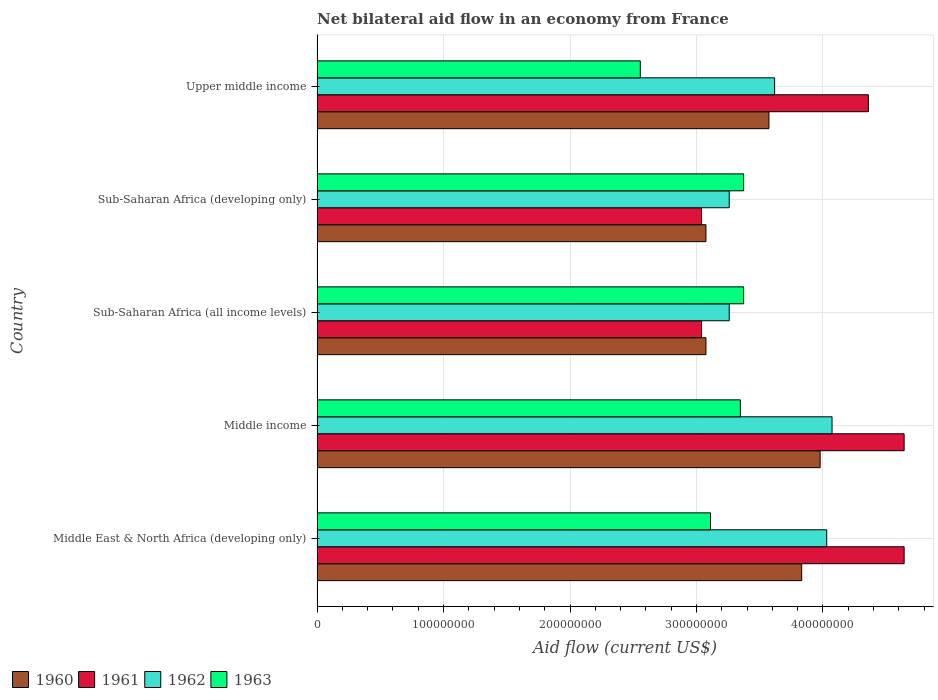Are the number of bars per tick equal to the number of legend labels?
Your answer should be very brief. Yes. In how many cases, is the number of bars for a given country not equal to the number of legend labels?
Your response must be concise. 0. What is the net bilateral aid flow in 1963 in Sub-Saharan Africa (developing only)?
Make the answer very short. 3.37e+08. Across all countries, what is the maximum net bilateral aid flow in 1963?
Ensure brevity in your answer.  3.37e+08. Across all countries, what is the minimum net bilateral aid flow in 1960?
Give a very brief answer. 3.08e+08. In which country was the net bilateral aid flow in 1961 maximum?
Ensure brevity in your answer.  Middle East & North Africa (developing only). In which country was the net bilateral aid flow in 1960 minimum?
Offer a terse response. Sub-Saharan Africa (all income levels). What is the total net bilateral aid flow in 1963 in the graph?
Provide a short and direct response. 1.58e+09. What is the difference between the net bilateral aid flow in 1963 in Sub-Saharan Africa (all income levels) and the net bilateral aid flow in 1962 in Middle income?
Give a very brief answer. -6.99e+07. What is the average net bilateral aid flow in 1960 per country?
Your answer should be compact. 3.51e+08. What is the difference between the net bilateral aid flow in 1963 and net bilateral aid flow in 1962 in Middle East & North Africa (developing only)?
Ensure brevity in your answer.  -9.19e+07. What is the ratio of the net bilateral aid flow in 1961 in Middle income to that in Sub-Saharan Africa (all income levels)?
Your response must be concise. 1.53. Is the net bilateral aid flow in 1960 in Sub-Saharan Africa (all income levels) less than that in Upper middle income?
Give a very brief answer. Yes. Is the difference between the net bilateral aid flow in 1963 in Sub-Saharan Africa (all income levels) and Upper middle income greater than the difference between the net bilateral aid flow in 1962 in Sub-Saharan Africa (all income levels) and Upper middle income?
Your answer should be very brief. Yes. What is the difference between the highest and the second highest net bilateral aid flow in 1960?
Offer a very short reply. 1.46e+07. What is the difference between the highest and the lowest net bilateral aid flow in 1962?
Offer a very short reply. 8.13e+07. Is it the case that in every country, the sum of the net bilateral aid flow in 1962 and net bilateral aid flow in 1963 is greater than the sum of net bilateral aid flow in 1961 and net bilateral aid flow in 1960?
Provide a succinct answer. No. How many bars are there?
Give a very brief answer. 20. How many countries are there in the graph?
Your answer should be very brief. 5. What is the difference between two consecutive major ticks on the X-axis?
Provide a short and direct response. 1.00e+08. Are the values on the major ticks of X-axis written in scientific E-notation?
Offer a very short reply. No. Does the graph contain any zero values?
Provide a succinct answer. No. Does the graph contain grids?
Make the answer very short. Yes. Where does the legend appear in the graph?
Provide a succinct answer. Bottom left. What is the title of the graph?
Make the answer very short. Net bilateral aid flow in an economy from France. What is the label or title of the X-axis?
Give a very brief answer. Aid flow (current US$). What is the Aid flow (current US$) in 1960 in Middle East & North Africa (developing only)?
Offer a very short reply. 3.83e+08. What is the Aid flow (current US$) of 1961 in Middle East & North Africa (developing only)?
Offer a very short reply. 4.64e+08. What is the Aid flow (current US$) in 1962 in Middle East & North Africa (developing only)?
Give a very brief answer. 4.03e+08. What is the Aid flow (current US$) in 1963 in Middle East & North Africa (developing only)?
Keep it short and to the point. 3.11e+08. What is the Aid flow (current US$) in 1960 in Middle income?
Provide a short and direct response. 3.98e+08. What is the Aid flow (current US$) of 1961 in Middle income?
Offer a terse response. 4.64e+08. What is the Aid flow (current US$) of 1962 in Middle income?
Give a very brief answer. 4.07e+08. What is the Aid flow (current US$) of 1963 in Middle income?
Provide a succinct answer. 3.35e+08. What is the Aid flow (current US$) of 1960 in Sub-Saharan Africa (all income levels)?
Provide a succinct answer. 3.08e+08. What is the Aid flow (current US$) in 1961 in Sub-Saharan Africa (all income levels)?
Give a very brief answer. 3.04e+08. What is the Aid flow (current US$) in 1962 in Sub-Saharan Africa (all income levels)?
Provide a succinct answer. 3.26e+08. What is the Aid flow (current US$) in 1963 in Sub-Saharan Africa (all income levels)?
Offer a very short reply. 3.37e+08. What is the Aid flow (current US$) in 1960 in Sub-Saharan Africa (developing only)?
Provide a succinct answer. 3.08e+08. What is the Aid flow (current US$) of 1961 in Sub-Saharan Africa (developing only)?
Give a very brief answer. 3.04e+08. What is the Aid flow (current US$) in 1962 in Sub-Saharan Africa (developing only)?
Offer a very short reply. 3.26e+08. What is the Aid flow (current US$) of 1963 in Sub-Saharan Africa (developing only)?
Keep it short and to the point. 3.37e+08. What is the Aid flow (current US$) of 1960 in Upper middle income?
Provide a short and direct response. 3.57e+08. What is the Aid flow (current US$) in 1961 in Upper middle income?
Ensure brevity in your answer.  4.36e+08. What is the Aid flow (current US$) of 1962 in Upper middle income?
Make the answer very short. 3.62e+08. What is the Aid flow (current US$) in 1963 in Upper middle income?
Your response must be concise. 2.56e+08. Across all countries, what is the maximum Aid flow (current US$) in 1960?
Provide a short and direct response. 3.98e+08. Across all countries, what is the maximum Aid flow (current US$) of 1961?
Provide a succinct answer. 4.64e+08. Across all countries, what is the maximum Aid flow (current US$) in 1962?
Ensure brevity in your answer.  4.07e+08. Across all countries, what is the maximum Aid flow (current US$) in 1963?
Keep it short and to the point. 3.37e+08. Across all countries, what is the minimum Aid flow (current US$) in 1960?
Your answer should be very brief. 3.08e+08. Across all countries, what is the minimum Aid flow (current US$) of 1961?
Make the answer very short. 3.04e+08. Across all countries, what is the minimum Aid flow (current US$) of 1962?
Your response must be concise. 3.26e+08. Across all countries, what is the minimum Aid flow (current US$) of 1963?
Ensure brevity in your answer.  2.56e+08. What is the total Aid flow (current US$) in 1960 in the graph?
Ensure brevity in your answer.  1.75e+09. What is the total Aid flow (current US$) of 1961 in the graph?
Give a very brief answer. 1.97e+09. What is the total Aid flow (current US$) of 1962 in the graph?
Ensure brevity in your answer.  1.82e+09. What is the total Aid flow (current US$) in 1963 in the graph?
Give a very brief answer. 1.58e+09. What is the difference between the Aid flow (current US$) in 1960 in Middle East & North Africa (developing only) and that in Middle income?
Offer a terse response. -1.46e+07. What is the difference between the Aid flow (current US$) of 1961 in Middle East & North Africa (developing only) and that in Middle income?
Offer a very short reply. 0. What is the difference between the Aid flow (current US$) of 1962 in Middle East & North Africa (developing only) and that in Middle income?
Your response must be concise. -4.20e+06. What is the difference between the Aid flow (current US$) of 1963 in Middle East & North Africa (developing only) and that in Middle income?
Make the answer very short. -2.36e+07. What is the difference between the Aid flow (current US$) of 1960 in Middle East & North Africa (developing only) and that in Sub-Saharan Africa (all income levels)?
Provide a short and direct response. 7.57e+07. What is the difference between the Aid flow (current US$) in 1961 in Middle East & North Africa (developing only) and that in Sub-Saharan Africa (all income levels)?
Your response must be concise. 1.60e+08. What is the difference between the Aid flow (current US$) in 1962 in Middle East & North Africa (developing only) and that in Sub-Saharan Africa (all income levels)?
Give a very brief answer. 7.71e+07. What is the difference between the Aid flow (current US$) in 1963 in Middle East & North Africa (developing only) and that in Sub-Saharan Africa (all income levels)?
Provide a succinct answer. -2.62e+07. What is the difference between the Aid flow (current US$) of 1960 in Middle East & North Africa (developing only) and that in Sub-Saharan Africa (developing only)?
Make the answer very short. 7.57e+07. What is the difference between the Aid flow (current US$) of 1961 in Middle East & North Africa (developing only) and that in Sub-Saharan Africa (developing only)?
Offer a very short reply. 1.60e+08. What is the difference between the Aid flow (current US$) of 1962 in Middle East & North Africa (developing only) and that in Sub-Saharan Africa (developing only)?
Provide a short and direct response. 7.71e+07. What is the difference between the Aid flow (current US$) in 1963 in Middle East & North Africa (developing only) and that in Sub-Saharan Africa (developing only)?
Offer a very short reply. -2.62e+07. What is the difference between the Aid flow (current US$) of 1960 in Middle East & North Africa (developing only) and that in Upper middle income?
Your answer should be very brief. 2.59e+07. What is the difference between the Aid flow (current US$) in 1961 in Middle East & North Africa (developing only) and that in Upper middle income?
Offer a terse response. 2.83e+07. What is the difference between the Aid flow (current US$) in 1962 in Middle East & North Africa (developing only) and that in Upper middle income?
Offer a very short reply. 4.12e+07. What is the difference between the Aid flow (current US$) of 1963 in Middle East & North Africa (developing only) and that in Upper middle income?
Ensure brevity in your answer.  5.55e+07. What is the difference between the Aid flow (current US$) in 1960 in Middle income and that in Sub-Saharan Africa (all income levels)?
Provide a short and direct response. 9.03e+07. What is the difference between the Aid flow (current US$) in 1961 in Middle income and that in Sub-Saharan Africa (all income levels)?
Give a very brief answer. 1.60e+08. What is the difference between the Aid flow (current US$) of 1962 in Middle income and that in Sub-Saharan Africa (all income levels)?
Offer a terse response. 8.13e+07. What is the difference between the Aid flow (current US$) of 1963 in Middle income and that in Sub-Saharan Africa (all income levels)?
Your response must be concise. -2.60e+06. What is the difference between the Aid flow (current US$) in 1960 in Middle income and that in Sub-Saharan Africa (developing only)?
Keep it short and to the point. 9.03e+07. What is the difference between the Aid flow (current US$) in 1961 in Middle income and that in Sub-Saharan Africa (developing only)?
Your answer should be compact. 1.60e+08. What is the difference between the Aid flow (current US$) in 1962 in Middle income and that in Sub-Saharan Africa (developing only)?
Your answer should be very brief. 8.13e+07. What is the difference between the Aid flow (current US$) in 1963 in Middle income and that in Sub-Saharan Africa (developing only)?
Make the answer very short. -2.60e+06. What is the difference between the Aid flow (current US$) in 1960 in Middle income and that in Upper middle income?
Provide a succinct answer. 4.05e+07. What is the difference between the Aid flow (current US$) in 1961 in Middle income and that in Upper middle income?
Ensure brevity in your answer.  2.83e+07. What is the difference between the Aid flow (current US$) of 1962 in Middle income and that in Upper middle income?
Give a very brief answer. 4.54e+07. What is the difference between the Aid flow (current US$) in 1963 in Middle income and that in Upper middle income?
Your response must be concise. 7.91e+07. What is the difference between the Aid flow (current US$) in 1960 in Sub-Saharan Africa (all income levels) and that in Upper middle income?
Keep it short and to the point. -4.98e+07. What is the difference between the Aid flow (current US$) of 1961 in Sub-Saharan Africa (all income levels) and that in Upper middle income?
Make the answer very short. -1.32e+08. What is the difference between the Aid flow (current US$) of 1962 in Sub-Saharan Africa (all income levels) and that in Upper middle income?
Your response must be concise. -3.59e+07. What is the difference between the Aid flow (current US$) in 1963 in Sub-Saharan Africa (all income levels) and that in Upper middle income?
Give a very brief answer. 8.17e+07. What is the difference between the Aid flow (current US$) of 1960 in Sub-Saharan Africa (developing only) and that in Upper middle income?
Your answer should be compact. -4.98e+07. What is the difference between the Aid flow (current US$) of 1961 in Sub-Saharan Africa (developing only) and that in Upper middle income?
Your response must be concise. -1.32e+08. What is the difference between the Aid flow (current US$) of 1962 in Sub-Saharan Africa (developing only) and that in Upper middle income?
Keep it short and to the point. -3.59e+07. What is the difference between the Aid flow (current US$) of 1963 in Sub-Saharan Africa (developing only) and that in Upper middle income?
Make the answer very short. 8.17e+07. What is the difference between the Aid flow (current US$) of 1960 in Middle East & North Africa (developing only) and the Aid flow (current US$) of 1961 in Middle income?
Provide a succinct answer. -8.10e+07. What is the difference between the Aid flow (current US$) in 1960 in Middle East & North Africa (developing only) and the Aid flow (current US$) in 1962 in Middle income?
Your answer should be very brief. -2.40e+07. What is the difference between the Aid flow (current US$) of 1960 in Middle East & North Africa (developing only) and the Aid flow (current US$) of 1963 in Middle income?
Ensure brevity in your answer.  4.85e+07. What is the difference between the Aid flow (current US$) in 1961 in Middle East & North Africa (developing only) and the Aid flow (current US$) in 1962 in Middle income?
Give a very brief answer. 5.70e+07. What is the difference between the Aid flow (current US$) in 1961 in Middle East & North Africa (developing only) and the Aid flow (current US$) in 1963 in Middle income?
Offer a very short reply. 1.30e+08. What is the difference between the Aid flow (current US$) of 1962 in Middle East & North Africa (developing only) and the Aid flow (current US$) of 1963 in Middle income?
Keep it short and to the point. 6.83e+07. What is the difference between the Aid flow (current US$) of 1960 in Middle East & North Africa (developing only) and the Aid flow (current US$) of 1961 in Sub-Saharan Africa (all income levels)?
Give a very brief answer. 7.92e+07. What is the difference between the Aid flow (current US$) of 1960 in Middle East & North Africa (developing only) and the Aid flow (current US$) of 1962 in Sub-Saharan Africa (all income levels)?
Offer a very short reply. 5.73e+07. What is the difference between the Aid flow (current US$) in 1960 in Middle East & North Africa (developing only) and the Aid flow (current US$) in 1963 in Sub-Saharan Africa (all income levels)?
Provide a short and direct response. 4.59e+07. What is the difference between the Aid flow (current US$) of 1961 in Middle East & North Africa (developing only) and the Aid flow (current US$) of 1962 in Sub-Saharan Africa (all income levels)?
Provide a succinct answer. 1.38e+08. What is the difference between the Aid flow (current US$) in 1961 in Middle East & North Africa (developing only) and the Aid flow (current US$) in 1963 in Sub-Saharan Africa (all income levels)?
Make the answer very short. 1.27e+08. What is the difference between the Aid flow (current US$) of 1962 in Middle East & North Africa (developing only) and the Aid flow (current US$) of 1963 in Sub-Saharan Africa (all income levels)?
Your answer should be compact. 6.57e+07. What is the difference between the Aid flow (current US$) of 1960 in Middle East & North Africa (developing only) and the Aid flow (current US$) of 1961 in Sub-Saharan Africa (developing only)?
Offer a terse response. 7.92e+07. What is the difference between the Aid flow (current US$) in 1960 in Middle East & North Africa (developing only) and the Aid flow (current US$) in 1962 in Sub-Saharan Africa (developing only)?
Make the answer very short. 5.73e+07. What is the difference between the Aid flow (current US$) of 1960 in Middle East & North Africa (developing only) and the Aid flow (current US$) of 1963 in Sub-Saharan Africa (developing only)?
Give a very brief answer. 4.59e+07. What is the difference between the Aid flow (current US$) of 1961 in Middle East & North Africa (developing only) and the Aid flow (current US$) of 1962 in Sub-Saharan Africa (developing only)?
Offer a terse response. 1.38e+08. What is the difference between the Aid flow (current US$) in 1961 in Middle East & North Africa (developing only) and the Aid flow (current US$) in 1963 in Sub-Saharan Africa (developing only)?
Your answer should be compact. 1.27e+08. What is the difference between the Aid flow (current US$) in 1962 in Middle East & North Africa (developing only) and the Aid flow (current US$) in 1963 in Sub-Saharan Africa (developing only)?
Provide a short and direct response. 6.57e+07. What is the difference between the Aid flow (current US$) in 1960 in Middle East & North Africa (developing only) and the Aid flow (current US$) in 1961 in Upper middle income?
Ensure brevity in your answer.  -5.27e+07. What is the difference between the Aid flow (current US$) of 1960 in Middle East & North Africa (developing only) and the Aid flow (current US$) of 1962 in Upper middle income?
Keep it short and to the point. 2.14e+07. What is the difference between the Aid flow (current US$) of 1960 in Middle East & North Africa (developing only) and the Aid flow (current US$) of 1963 in Upper middle income?
Provide a succinct answer. 1.28e+08. What is the difference between the Aid flow (current US$) of 1961 in Middle East & North Africa (developing only) and the Aid flow (current US$) of 1962 in Upper middle income?
Provide a succinct answer. 1.02e+08. What is the difference between the Aid flow (current US$) in 1961 in Middle East & North Africa (developing only) and the Aid flow (current US$) in 1963 in Upper middle income?
Offer a very short reply. 2.09e+08. What is the difference between the Aid flow (current US$) in 1962 in Middle East & North Africa (developing only) and the Aid flow (current US$) in 1963 in Upper middle income?
Your answer should be very brief. 1.47e+08. What is the difference between the Aid flow (current US$) of 1960 in Middle income and the Aid flow (current US$) of 1961 in Sub-Saharan Africa (all income levels)?
Ensure brevity in your answer.  9.38e+07. What is the difference between the Aid flow (current US$) in 1960 in Middle income and the Aid flow (current US$) in 1962 in Sub-Saharan Africa (all income levels)?
Your response must be concise. 7.19e+07. What is the difference between the Aid flow (current US$) of 1960 in Middle income and the Aid flow (current US$) of 1963 in Sub-Saharan Africa (all income levels)?
Make the answer very short. 6.05e+07. What is the difference between the Aid flow (current US$) in 1961 in Middle income and the Aid flow (current US$) in 1962 in Sub-Saharan Africa (all income levels)?
Provide a short and direct response. 1.38e+08. What is the difference between the Aid flow (current US$) of 1961 in Middle income and the Aid flow (current US$) of 1963 in Sub-Saharan Africa (all income levels)?
Provide a short and direct response. 1.27e+08. What is the difference between the Aid flow (current US$) in 1962 in Middle income and the Aid flow (current US$) in 1963 in Sub-Saharan Africa (all income levels)?
Provide a short and direct response. 6.99e+07. What is the difference between the Aid flow (current US$) in 1960 in Middle income and the Aid flow (current US$) in 1961 in Sub-Saharan Africa (developing only)?
Keep it short and to the point. 9.38e+07. What is the difference between the Aid flow (current US$) of 1960 in Middle income and the Aid flow (current US$) of 1962 in Sub-Saharan Africa (developing only)?
Make the answer very short. 7.19e+07. What is the difference between the Aid flow (current US$) in 1960 in Middle income and the Aid flow (current US$) in 1963 in Sub-Saharan Africa (developing only)?
Your answer should be very brief. 6.05e+07. What is the difference between the Aid flow (current US$) in 1961 in Middle income and the Aid flow (current US$) in 1962 in Sub-Saharan Africa (developing only)?
Make the answer very short. 1.38e+08. What is the difference between the Aid flow (current US$) in 1961 in Middle income and the Aid flow (current US$) in 1963 in Sub-Saharan Africa (developing only)?
Offer a terse response. 1.27e+08. What is the difference between the Aid flow (current US$) of 1962 in Middle income and the Aid flow (current US$) of 1963 in Sub-Saharan Africa (developing only)?
Provide a succinct answer. 6.99e+07. What is the difference between the Aid flow (current US$) in 1960 in Middle income and the Aid flow (current US$) in 1961 in Upper middle income?
Provide a succinct answer. -3.81e+07. What is the difference between the Aid flow (current US$) of 1960 in Middle income and the Aid flow (current US$) of 1962 in Upper middle income?
Keep it short and to the point. 3.60e+07. What is the difference between the Aid flow (current US$) of 1960 in Middle income and the Aid flow (current US$) of 1963 in Upper middle income?
Offer a terse response. 1.42e+08. What is the difference between the Aid flow (current US$) in 1961 in Middle income and the Aid flow (current US$) in 1962 in Upper middle income?
Offer a terse response. 1.02e+08. What is the difference between the Aid flow (current US$) in 1961 in Middle income and the Aid flow (current US$) in 1963 in Upper middle income?
Give a very brief answer. 2.09e+08. What is the difference between the Aid flow (current US$) in 1962 in Middle income and the Aid flow (current US$) in 1963 in Upper middle income?
Ensure brevity in your answer.  1.52e+08. What is the difference between the Aid flow (current US$) of 1960 in Sub-Saharan Africa (all income levels) and the Aid flow (current US$) of 1961 in Sub-Saharan Africa (developing only)?
Your answer should be very brief. 3.50e+06. What is the difference between the Aid flow (current US$) in 1960 in Sub-Saharan Africa (all income levels) and the Aid flow (current US$) in 1962 in Sub-Saharan Africa (developing only)?
Give a very brief answer. -1.84e+07. What is the difference between the Aid flow (current US$) in 1960 in Sub-Saharan Africa (all income levels) and the Aid flow (current US$) in 1963 in Sub-Saharan Africa (developing only)?
Offer a terse response. -2.98e+07. What is the difference between the Aid flow (current US$) in 1961 in Sub-Saharan Africa (all income levels) and the Aid flow (current US$) in 1962 in Sub-Saharan Africa (developing only)?
Ensure brevity in your answer.  -2.19e+07. What is the difference between the Aid flow (current US$) in 1961 in Sub-Saharan Africa (all income levels) and the Aid flow (current US$) in 1963 in Sub-Saharan Africa (developing only)?
Your answer should be compact. -3.33e+07. What is the difference between the Aid flow (current US$) of 1962 in Sub-Saharan Africa (all income levels) and the Aid flow (current US$) of 1963 in Sub-Saharan Africa (developing only)?
Offer a very short reply. -1.14e+07. What is the difference between the Aid flow (current US$) in 1960 in Sub-Saharan Africa (all income levels) and the Aid flow (current US$) in 1961 in Upper middle income?
Your answer should be very brief. -1.28e+08. What is the difference between the Aid flow (current US$) in 1960 in Sub-Saharan Africa (all income levels) and the Aid flow (current US$) in 1962 in Upper middle income?
Your response must be concise. -5.43e+07. What is the difference between the Aid flow (current US$) in 1960 in Sub-Saharan Africa (all income levels) and the Aid flow (current US$) in 1963 in Upper middle income?
Your response must be concise. 5.19e+07. What is the difference between the Aid flow (current US$) in 1961 in Sub-Saharan Africa (all income levels) and the Aid flow (current US$) in 1962 in Upper middle income?
Your answer should be compact. -5.78e+07. What is the difference between the Aid flow (current US$) of 1961 in Sub-Saharan Africa (all income levels) and the Aid flow (current US$) of 1963 in Upper middle income?
Make the answer very short. 4.84e+07. What is the difference between the Aid flow (current US$) in 1962 in Sub-Saharan Africa (all income levels) and the Aid flow (current US$) in 1963 in Upper middle income?
Offer a very short reply. 7.03e+07. What is the difference between the Aid flow (current US$) of 1960 in Sub-Saharan Africa (developing only) and the Aid flow (current US$) of 1961 in Upper middle income?
Offer a terse response. -1.28e+08. What is the difference between the Aid flow (current US$) of 1960 in Sub-Saharan Africa (developing only) and the Aid flow (current US$) of 1962 in Upper middle income?
Your answer should be very brief. -5.43e+07. What is the difference between the Aid flow (current US$) of 1960 in Sub-Saharan Africa (developing only) and the Aid flow (current US$) of 1963 in Upper middle income?
Make the answer very short. 5.19e+07. What is the difference between the Aid flow (current US$) in 1961 in Sub-Saharan Africa (developing only) and the Aid flow (current US$) in 1962 in Upper middle income?
Give a very brief answer. -5.78e+07. What is the difference between the Aid flow (current US$) of 1961 in Sub-Saharan Africa (developing only) and the Aid flow (current US$) of 1963 in Upper middle income?
Offer a terse response. 4.84e+07. What is the difference between the Aid flow (current US$) of 1962 in Sub-Saharan Africa (developing only) and the Aid flow (current US$) of 1963 in Upper middle income?
Ensure brevity in your answer.  7.03e+07. What is the average Aid flow (current US$) of 1960 per country?
Your response must be concise. 3.51e+08. What is the average Aid flow (current US$) of 1961 per country?
Give a very brief answer. 3.94e+08. What is the average Aid flow (current US$) in 1962 per country?
Your response must be concise. 3.65e+08. What is the average Aid flow (current US$) in 1963 per country?
Keep it short and to the point. 3.15e+08. What is the difference between the Aid flow (current US$) of 1960 and Aid flow (current US$) of 1961 in Middle East & North Africa (developing only)?
Keep it short and to the point. -8.10e+07. What is the difference between the Aid flow (current US$) of 1960 and Aid flow (current US$) of 1962 in Middle East & North Africa (developing only)?
Offer a terse response. -1.98e+07. What is the difference between the Aid flow (current US$) of 1960 and Aid flow (current US$) of 1963 in Middle East & North Africa (developing only)?
Your answer should be very brief. 7.21e+07. What is the difference between the Aid flow (current US$) of 1961 and Aid flow (current US$) of 1962 in Middle East & North Africa (developing only)?
Make the answer very short. 6.12e+07. What is the difference between the Aid flow (current US$) in 1961 and Aid flow (current US$) in 1963 in Middle East & North Africa (developing only)?
Offer a terse response. 1.53e+08. What is the difference between the Aid flow (current US$) in 1962 and Aid flow (current US$) in 1963 in Middle East & North Africa (developing only)?
Offer a terse response. 9.19e+07. What is the difference between the Aid flow (current US$) of 1960 and Aid flow (current US$) of 1961 in Middle income?
Your response must be concise. -6.64e+07. What is the difference between the Aid flow (current US$) of 1960 and Aid flow (current US$) of 1962 in Middle income?
Make the answer very short. -9.40e+06. What is the difference between the Aid flow (current US$) of 1960 and Aid flow (current US$) of 1963 in Middle income?
Your answer should be compact. 6.31e+07. What is the difference between the Aid flow (current US$) of 1961 and Aid flow (current US$) of 1962 in Middle income?
Your response must be concise. 5.70e+07. What is the difference between the Aid flow (current US$) in 1961 and Aid flow (current US$) in 1963 in Middle income?
Make the answer very short. 1.30e+08. What is the difference between the Aid flow (current US$) of 1962 and Aid flow (current US$) of 1963 in Middle income?
Provide a short and direct response. 7.25e+07. What is the difference between the Aid flow (current US$) of 1960 and Aid flow (current US$) of 1961 in Sub-Saharan Africa (all income levels)?
Your answer should be very brief. 3.50e+06. What is the difference between the Aid flow (current US$) in 1960 and Aid flow (current US$) in 1962 in Sub-Saharan Africa (all income levels)?
Give a very brief answer. -1.84e+07. What is the difference between the Aid flow (current US$) in 1960 and Aid flow (current US$) in 1963 in Sub-Saharan Africa (all income levels)?
Make the answer very short. -2.98e+07. What is the difference between the Aid flow (current US$) of 1961 and Aid flow (current US$) of 1962 in Sub-Saharan Africa (all income levels)?
Provide a short and direct response. -2.19e+07. What is the difference between the Aid flow (current US$) of 1961 and Aid flow (current US$) of 1963 in Sub-Saharan Africa (all income levels)?
Provide a short and direct response. -3.33e+07. What is the difference between the Aid flow (current US$) of 1962 and Aid flow (current US$) of 1963 in Sub-Saharan Africa (all income levels)?
Ensure brevity in your answer.  -1.14e+07. What is the difference between the Aid flow (current US$) in 1960 and Aid flow (current US$) in 1961 in Sub-Saharan Africa (developing only)?
Provide a succinct answer. 3.50e+06. What is the difference between the Aid flow (current US$) in 1960 and Aid flow (current US$) in 1962 in Sub-Saharan Africa (developing only)?
Your response must be concise. -1.84e+07. What is the difference between the Aid flow (current US$) in 1960 and Aid flow (current US$) in 1963 in Sub-Saharan Africa (developing only)?
Ensure brevity in your answer.  -2.98e+07. What is the difference between the Aid flow (current US$) of 1961 and Aid flow (current US$) of 1962 in Sub-Saharan Africa (developing only)?
Make the answer very short. -2.19e+07. What is the difference between the Aid flow (current US$) in 1961 and Aid flow (current US$) in 1963 in Sub-Saharan Africa (developing only)?
Offer a terse response. -3.33e+07. What is the difference between the Aid flow (current US$) in 1962 and Aid flow (current US$) in 1963 in Sub-Saharan Africa (developing only)?
Your answer should be compact. -1.14e+07. What is the difference between the Aid flow (current US$) in 1960 and Aid flow (current US$) in 1961 in Upper middle income?
Provide a succinct answer. -7.86e+07. What is the difference between the Aid flow (current US$) of 1960 and Aid flow (current US$) of 1962 in Upper middle income?
Keep it short and to the point. -4.50e+06. What is the difference between the Aid flow (current US$) of 1960 and Aid flow (current US$) of 1963 in Upper middle income?
Your answer should be very brief. 1.02e+08. What is the difference between the Aid flow (current US$) of 1961 and Aid flow (current US$) of 1962 in Upper middle income?
Your answer should be very brief. 7.41e+07. What is the difference between the Aid flow (current US$) of 1961 and Aid flow (current US$) of 1963 in Upper middle income?
Offer a terse response. 1.80e+08. What is the difference between the Aid flow (current US$) in 1962 and Aid flow (current US$) in 1963 in Upper middle income?
Your answer should be compact. 1.06e+08. What is the ratio of the Aid flow (current US$) in 1960 in Middle East & North Africa (developing only) to that in Middle income?
Offer a very short reply. 0.96. What is the ratio of the Aid flow (current US$) of 1961 in Middle East & North Africa (developing only) to that in Middle income?
Keep it short and to the point. 1. What is the ratio of the Aid flow (current US$) in 1962 in Middle East & North Africa (developing only) to that in Middle income?
Offer a very short reply. 0.99. What is the ratio of the Aid flow (current US$) in 1963 in Middle East & North Africa (developing only) to that in Middle income?
Provide a succinct answer. 0.93. What is the ratio of the Aid flow (current US$) of 1960 in Middle East & North Africa (developing only) to that in Sub-Saharan Africa (all income levels)?
Your answer should be very brief. 1.25. What is the ratio of the Aid flow (current US$) in 1961 in Middle East & North Africa (developing only) to that in Sub-Saharan Africa (all income levels)?
Give a very brief answer. 1.53. What is the ratio of the Aid flow (current US$) of 1962 in Middle East & North Africa (developing only) to that in Sub-Saharan Africa (all income levels)?
Make the answer very short. 1.24. What is the ratio of the Aid flow (current US$) of 1963 in Middle East & North Africa (developing only) to that in Sub-Saharan Africa (all income levels)?
Keep it short and to the point. 0.92. What is the ratio of the Aid flow (current US$) in 1960 in Middle East & North Africa (developing only) to that in Sub-Saharan Africa (developing only)?
Your response must be concise. 1.25. What is the ratio of the Aid flow (current US$) of 1961 in Middle East & North Africa (developing only) to that in Sub-Saharan Africa (developing only)?
Make the answer very short. 1.53. What is the ratio of the Aid flow (current US$) in 1962 in Middle East & North Africa (developing only) to that in Sub-Saharan Africa (developing only)?
Offer a terse response. 1.24. What is the ratio of the Aid flow (current US$) in 1963 in Middle East & North Africa (developing only) to that in Sub-Saharan Africa (developing only)?
Offer a very short reply. 0.92. What is the ratio of the Aid flow (current US$) in 1960 in Middle East & North Africa (developing only) to that in Upper middle income?
Make the answer very short. 1.07. What is the ratio of the Aid flow (current US$) of 1961 in Middle East & North Africa (developing only) to that in Upper middle income?
Provide a succinct answer. 1.06. What is the ratio of the Aid flow (current US$) in 1962 in Middle East & North Africa (developing only) to that in Upper middle income?
Your response must be concise. 1.11. What is the ratio of the Aid flow (current US$) of 1963 in Middle East & North Africa (developing only) to that in Upper middle income?
Your answer should be compact. 1.22. What is the ratio of the Aid flow (current US$) in 1960 in Middle income to that in Sub-Saharan Africa (all income levels)?
Provide a succinct answer. 1.29. What is the ratio of the Aid flow (current US$) of 1961 in Middle income to that in Sub-Saharan Africa (all income levels)?
Ensure brevity in your answer.  1.53. What is the ratio of the Aid flow (current US$) of 1962 in Middle income to that in Sub-Saharan Africa (all income levels)?
Offer a terse response. 1.25. What is the ratio of the Aid flow (current US$) of 1960 in Middle income to that in Sub-Saharan Africa (developing only)?
Your answer should be very brief. 1.29. What is the ratio of the Aid flow (current US$) of 1961 in Middle income to that in Sub-Saharan Africa (developing only)?
Keep it short and to the point. 1.53. What is the ratio of the Aid flow (current US$) in 1962 in Middle income to that in Sub-Saharan Africa (developing only)?
Make the answer very short. 1.25. What is the ratio of the Aid flow (current US$) in 1963 in Middle income to that in Sub-Saharan Africa (developing only)?
Provide a short and direct response. 0.99. What is the ratio of the Aid flow (current US$) in 1960 in Middle income to that in Upper middle income?
Offer a very short reply. 1.11. What is the ratio of the Aid flow (current US$) of 1961 in Middle income to that in Upper middle income?
Make the answer very short. 1.06. What is the ratio of the Aid flow (current US$) of 1962 in Middle income to that in Upper middle income?
Offer a very short reply. 1.13. What is the ratio of the Aid flow (current US$) in 1963 in Middle income to that in Upper middle income?
Your response must be concise. 1.31. What is the ratio of the Aid flow (current US$) in 1962 in Sub-Saharan Africa (all income levels) to that in Sub-Saharan Africa (developing only)?
Provide a succinct answer. 1. What is the ratio of the Aid flow (current US$) of 1960 in Sub-Saharan Africa (all income levels) to that in Upper middle income?
Ensure brevity in your answer.  0.86. What is the ratio of the Aid flow (current US$) of 1961 in Sub-Saharan Africa (all income levels) to that in Upper middle income?
Provide a short and direct response. 0.7. What is the ratio of the Aid flow (current US$) in 1962 in Sub-Saharan Africa (all income levels) to that in Upper middle income?
Offer a terse response. 0.9. What is the ratio of the Aid flow (current US$) in 1963 in Sub-Saharan Africa (all income levels) to that in Upper middle income?
Make the answer very short. 1.32. What is the ratio of the Aid flow (current US$) of 1960 in Sub-Saharan Africa (developing only) to that in Upper middle income?
Provide a succinct answer. 0.86. What is the ratio of the Aid flow (current US$) of 1961 in Sub-Saharan Africa (developing only) to that in Upper middle income?
Offer a terse response. 0.7. What is the ratio of the Aid flow (current US$) in 1962 in Sub-Saharan Africa (developing only) to that in Upper middle income?
Offer a terse response. 0.9. What is the ratio of the Aid flow (current US$) in 1963 in Sub-Saharan Africa (developing only) to that in Upper middle income?
Ensure brevity in your answer.  1.32. What is the difference between the highest and the second highest Aid flow (current US$) in 1960?
Your answer should be compact. 1.46e+07. What is the difference between the highest and the second highest Aid flow (current US$) in 1961?
Make the answer very short. 0. What is the difference between the highest and the second highest Aid flow (current US$) of 1962?
Give a very brief answer. 4.20e+06. What is the difference between the highest and the second highest Aid flow (current US$) of 1963?
Provide a short and direct response. 0. What is the difference between the highest and the lowest Aid flow (current US$) in 1960?
Your response must be concise. 9.03e+07. What is the difference between the highest and the lowest Aid flow (current US$) in 1961?
Offer a very short reply. 1.60e+08. What is the difference between the highest and the lowest Aid flow (current US$) in 1962?
Your answer should be compact. 8.13e+07. What is the difference between the highest and the lowest Aid flow (current US$) of 1963?
Your answer should be compact. 8.17e+07. 